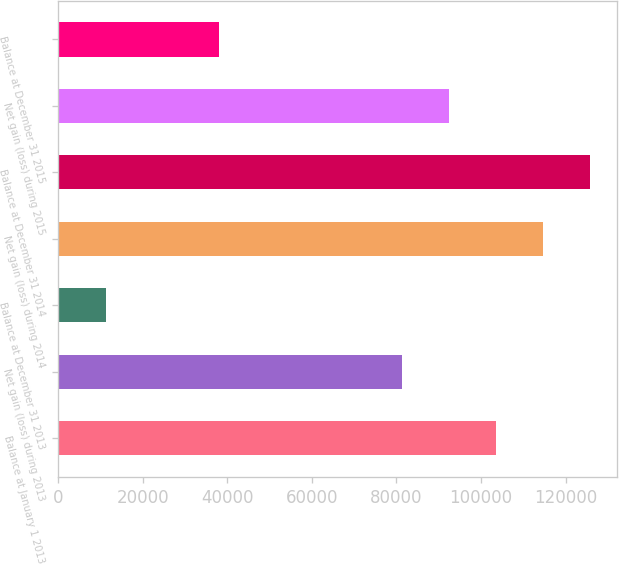Convert chart. <chart><loc_0><loc_0><loc_500><loc_500><bar_chart><fcel>Balance at January 1 2013<fcel>Net gain (loss) during 2013<fcel>Balance at December 31 2013<fcel>Net gain (loss) during 2014<fcel>Balance at December 31 2014<fcel>Net gain (loss) during 2015<fcel>Balance at December 31 2015<nl><fcel>103565<fcel>81287<fcel>11294<fcel>114704<fcel>125843<fcel>92425.9<fcel>38166<nl></chart> 